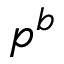<formula> <loc_0><loc_0><loc_500><loc_500>p ^ { b }</formula> 